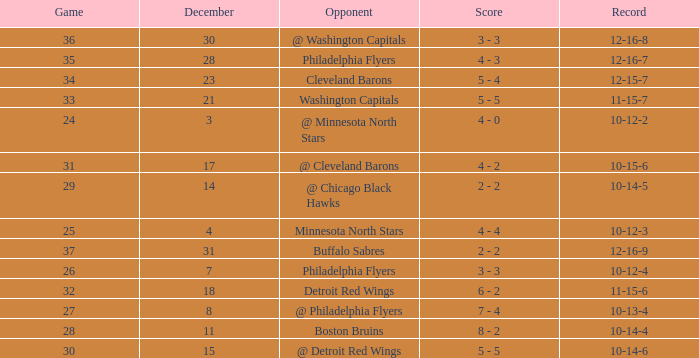What is Record, when Game is "24"? 10-12-2. 